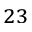<formula> <loc_0><loc_0><loc_500><loc_500>^ { 2 3 }</formula> 